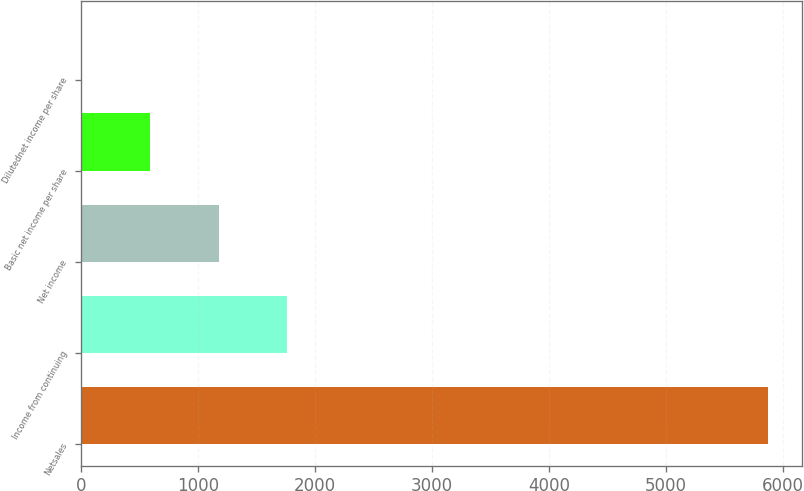Convert chart. <chart><loc_0><loc_0><loc_500><loc_500><bar_chart><fcel>Netsales<fcel>Income from continuing<fcel>Net income<fcel>Basic net income per share<fcel>Dilutednet income per share<nl><fcel>5869.9<fcel>1762.55<fcel>1175.78<fcel>589.01<fcel>2.25<nl></chart> 